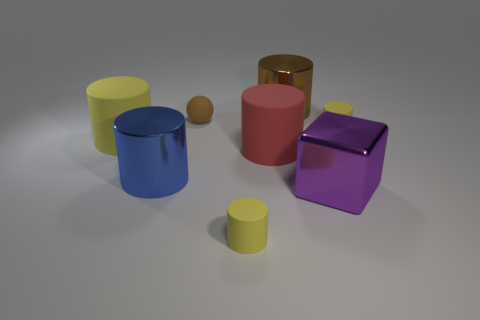How many objects are there in the image, and can you describe their shapes? There are six objects in the image. Starting from the left, there's a yellow cylinder, a large blue cylinder, a small orange sphere, a large red object resembling a rubber material, a golden cylinder, and finally, a purple metallic cube on the right. 